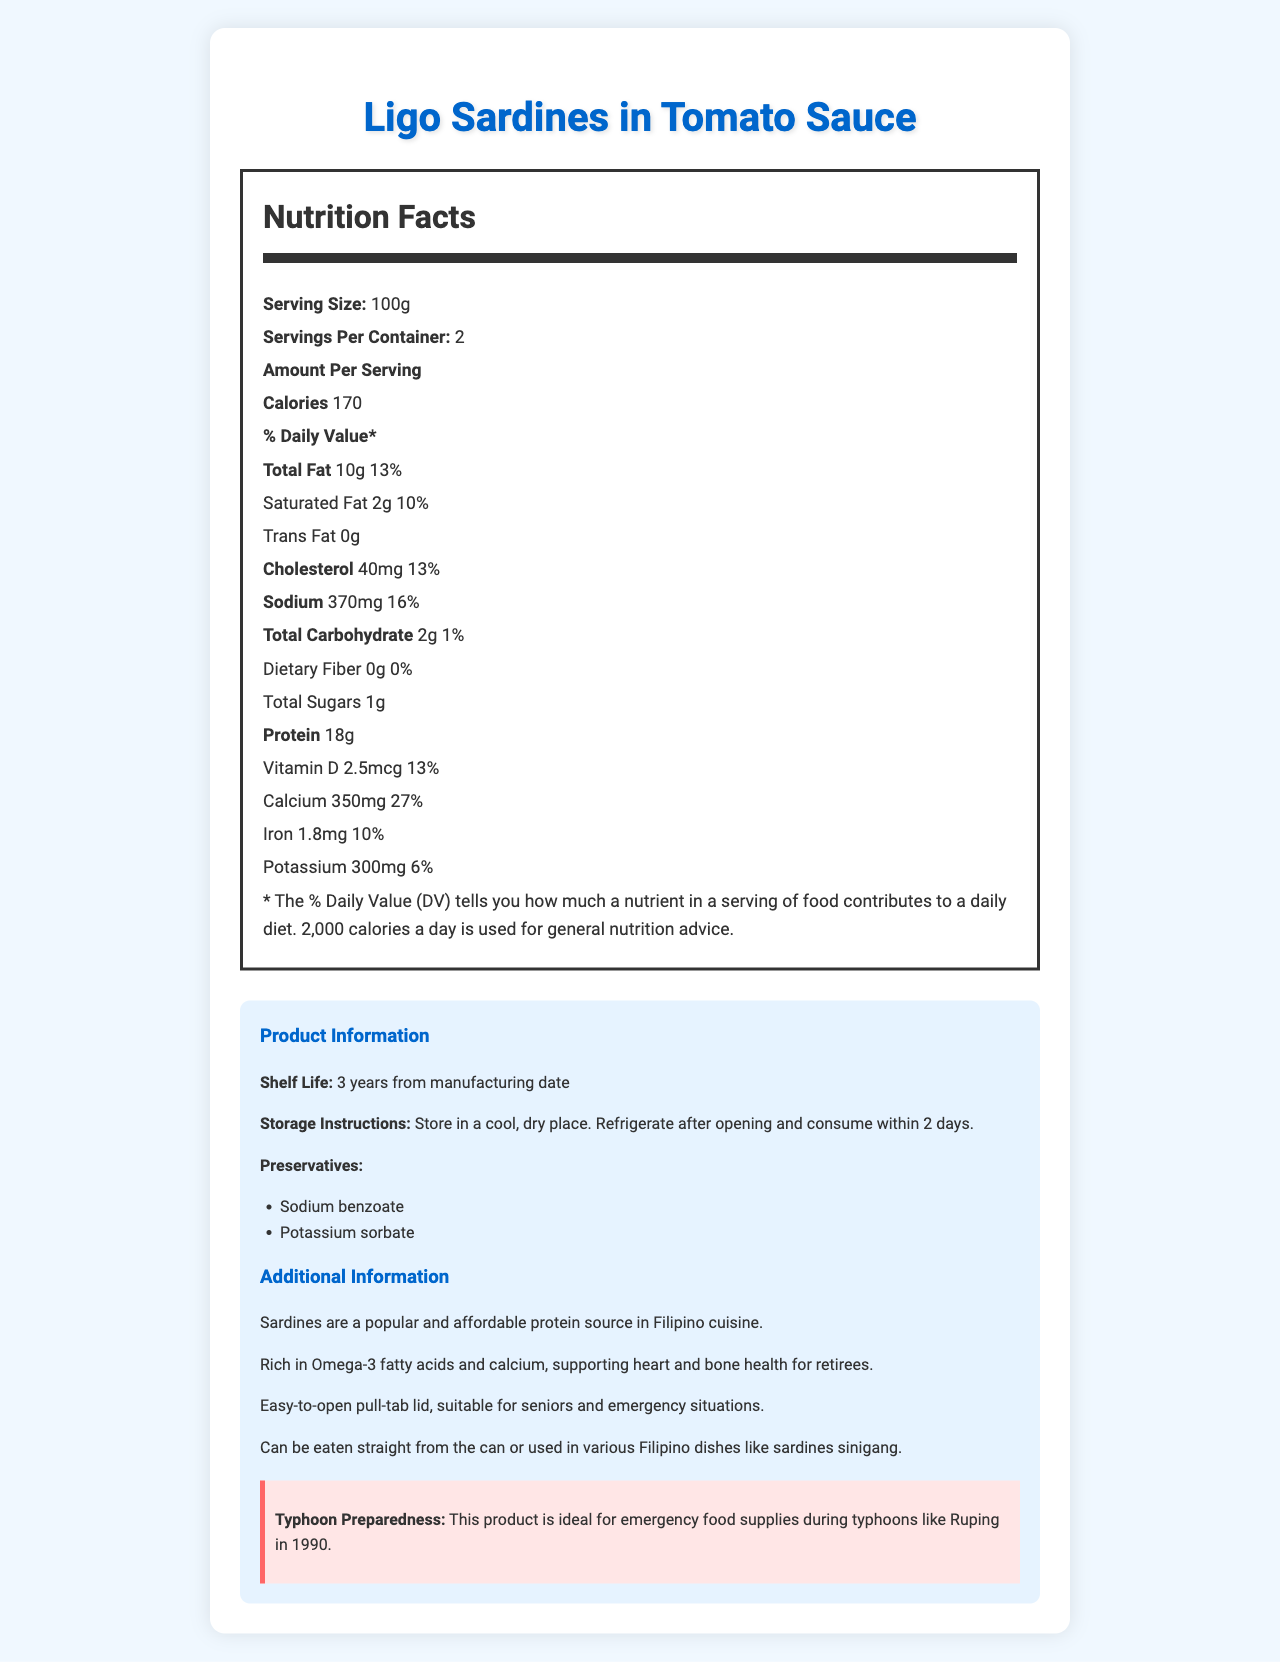what is the serving size for Ligo Sardines in Tomato Sauce? The document specifies "Serving Size: 100g" under the "Nutrition Facts" section.
Answer: 100g how many servings are there per container? The container provides "Servings Per Container: 2" as per the "Nutrition Facts" section.
Answer: 2 what are the preservatives used in Ligo Sardines in Tomato Sauce? The document lists the preservatives under "Preservatives" as "Sodium benzoate, Potassium sorbate".
Answer: Sodium benzoate and Potassium sorbate how long is the shelf life for this product? The "Product Information" section includes "Shelf Life: 3 years from manufacturing date".
Answer: 3 years from manufacturing date what is the daily value percentage of calcium per serving? The "Nutrition Facts" section mentions "Calcium 350mg 27%".
Answer: 27% what is the total amount of fat in one serving of Ligo Sardines in Tomato Sauce? The document under "Total Fat" states "10g".
Answer: 10g which of the following nutrients has the lowest daily value percentage per serving? A. Vitamin D B. Iron C. Potassium The daily value percentages noted are: Vitamin D 13%, Iron 10%, and Potassium 6%.
Answer: C. Potassium how much protein does one serving contain? A. 12g B. 14g C. 18g D. 20g The "Nutrition Facts" section lists "Protein 18g".
Answer: C. 18g are sardines a popular source of protein in Filipino cuisine? As per the "Additional Information" section, "Sardines are a popular and affordable protein source in Filipino cuisine."
Answer: Yes does the product need refrigeration before opening? The "Storage Instructions" specify refrigeration only after opening: "Refrigerate after opening and consume within 2 days."
Answer: No summarize the main idea of the nutrition facts label for Ligo Sardines in Tomato Sauce. The document showcases comprehensive nutrition facts and additional product information relevant to consumers, particularly those preparing for emergencies like typhoons.
Answer: The document provides detailed nutritional information for Ligo Sardines in Tomato Sauce, including serving size, calorie content, and the percentage of daily values for various nutrients. It also includes product-specific details such as preservatives, shelf life, and storage instructions, and additional information on its suitability for emergency use, cultural relevance, and nutritional benefits. how much dietary fiber is in one serving? The "Nutrition Facts" section states "Dietary Fiber 0g".
Answer: 0g what additional benefit does the document mention for retirees regarding the product? The "Additional Information" section mentions "Rich in Omega-3 fatty acids and calcium, supporting heart and bone health for retirees."
Answer: Supports heart and bone health how many calories are in one serving? The "Nutrition Facts" section shows "Calories 170".
Answer: 170 is the product easy to open for seniors? The "Additional Information" section states "Easy-to-open pull-tab lid, suitable for seniors and emergency situations."
Answer: Yes what flavors or sauces are mentioned in the product name? The document's product name specifies "Ligo Sardines in Tomato Sauce".
Answer: Tomato Sauce what is the iron content per serving in milligrams? The "Nutrition Facts" section mentions "Iron 1.8mg".
Answer: 1.8mg what is the source of detailed product information such as shelf life and preservatives? The section labeled "Product Information" provides details on shelf life, storage instructions, and preservatives.
Answer: The Product Information section 